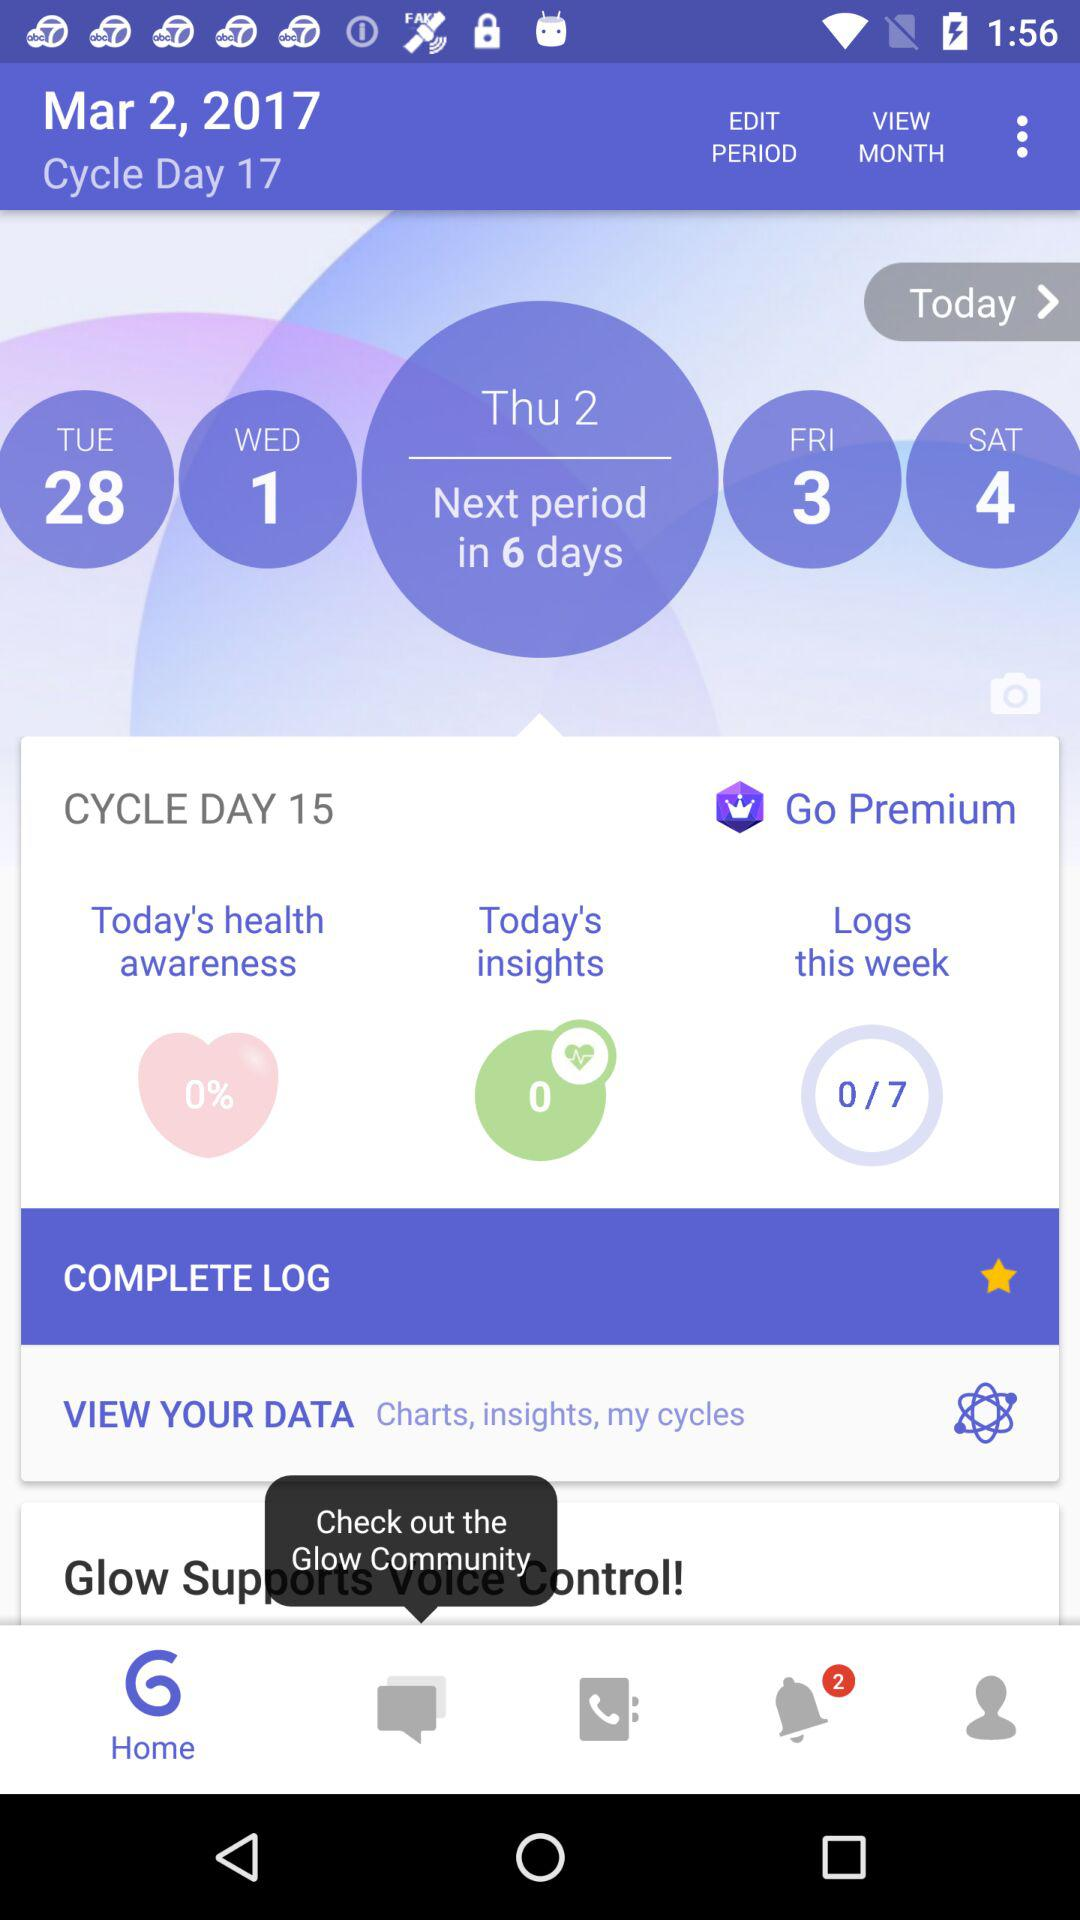How many days until the next period?
Answer the question using a single word or phrase. 6 days 